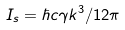Convert formula to latex. <formula><loc_0><loc_0><loc_500><loc_500>I _ { s } = \hbar { c } \gamma k ^ { 3 } / 1 2 \pi</formula> 